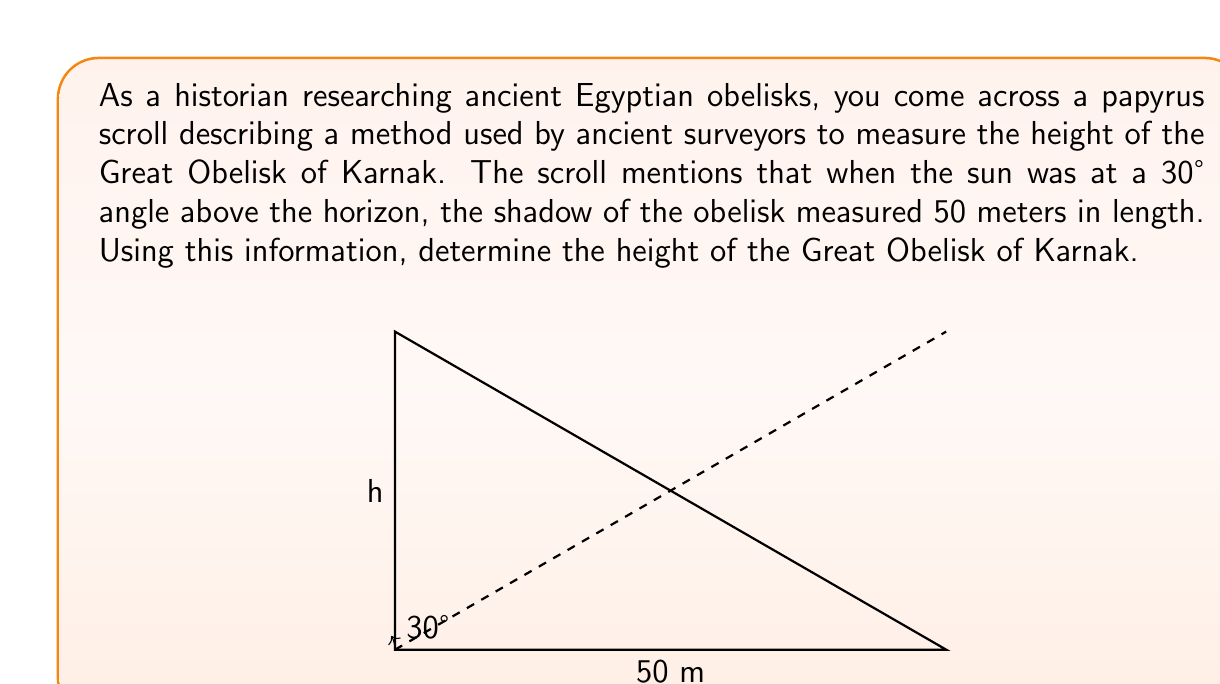Could you help me with this problem? Let's approach this step-by-step using trigonometry:

1) In this problem, we have a right triangle formed by the obelisk, its shadow, and the sun's rays.

2) We know:
   - The angle of the sun above the horizon is 30°
   - The length of the shadow is 50 meters
   - We need to find the height of the obelisk

3) In this right triangle:
   - The shadow length is the adjacent side to the 30° angle
   - The obelisk height is the opposite side to the 30° angle
   - We can use the tangent function to relate these

4) The tangent of an angle in a right triangle is the ratio of the opposite side to the adjacent side:

   $$\tan(\theta) = \frac{\text{opposite}}{\text{adjacent}}$$

5) In our case:

   $$\tan(30°) = \frac{\text{height}}{\text{shadow length}}$$

6) We know $\tan(30°) = \frac{1}{\sqrt{3}}$, so:

   $$\frac{1}{\sqrt{3}} = \frac{\text{height}}{50}$$

7) Cross multiply:

   $$\text{height} = 50 * \frac{1}{\sqrt{3}}$$

8) Simplify:

   $$\text{height} = \frac{50}{\sqrt{3}} \approx 28.87 \text{ meters}$$

Therefore, the height of the Great Obelisk of Karnak is approximately 28.87 meters.
Answer: The height of the Great Obelisk of Karnak is $\frac{50}{\sqrt{3}} \approx 28.87$ meters. 